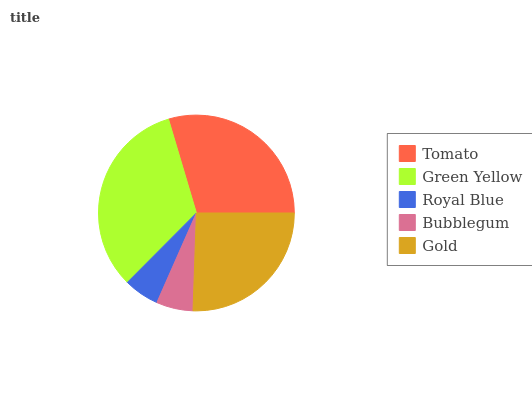Is Royal Blue the minimum?
Answer yes or no. Yes. Is Green Yellow the maximum?
Answer yes or no. Yes. Is Green Yellow the minimum?
Answer yes or no. No. Is Royal Blue the maximum?
Answer yes or no. No. Is Green Yellow greater than Royal Blue?
Answer yes or no. Yes. Is Royal Blue less than Green Yellow?
Answer yes or no. Yes. Is Royal Blue greater than Green Yellow?
Answer yes or no. No. Is Green Yellow less than Royal Blue?
Answer yes or no. No. Is Gold the high median?
Answer yes or no. Yes. Is Gold the low median?
Answer yes or no. Yes. Is Tomato the high median?
Answer yes or no. No. Is Royal Blue the low median?
Answer yes or no. No. 